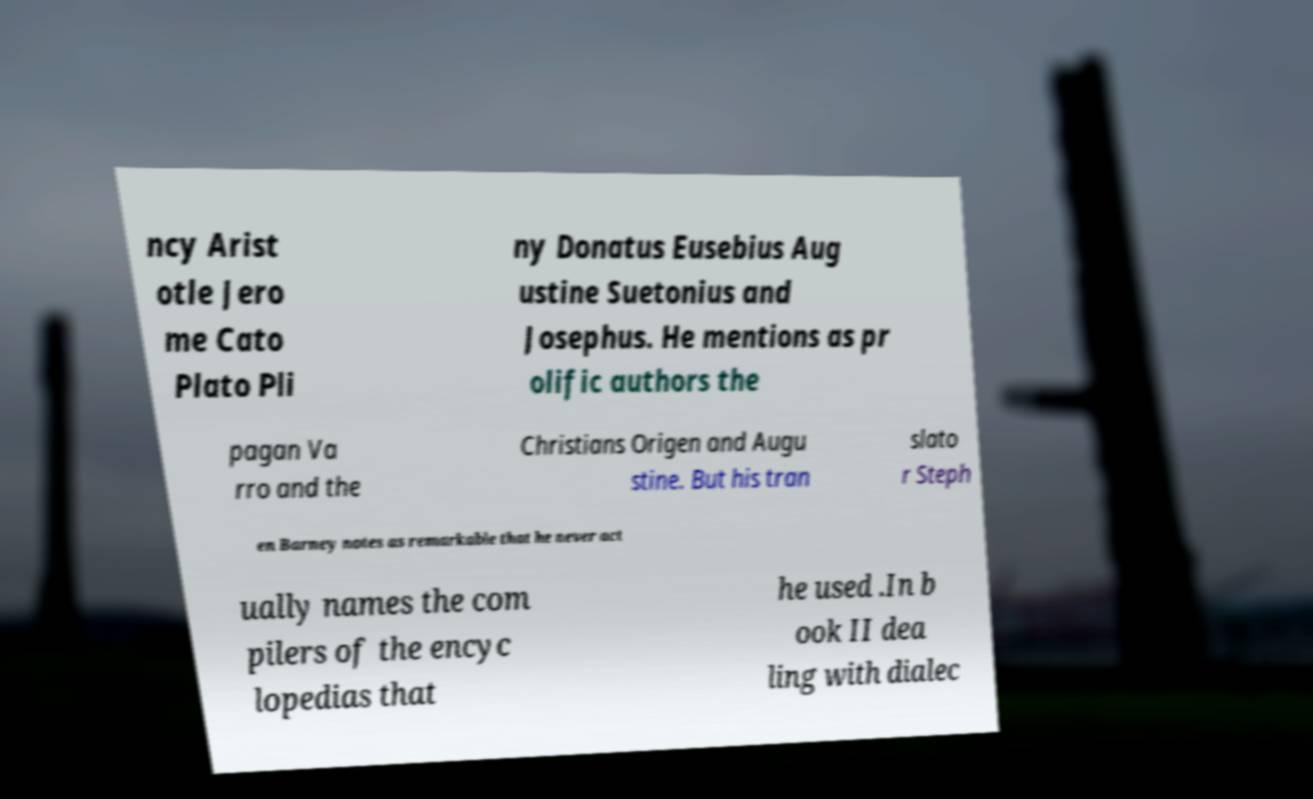Can you accurately transcribe the text from the provided image for me? ncy Arist otle Jero me Cato Plato Pli ny Donatus Eusebius Aug ustine Suetonius and Josephus. He mentions as pr olific authors the pagan Va rro and the Christians Origen and Augu stine. But his tran slato r Steph en Barney notes as remarkable that he never act ually names the com pilers of the encyc lopedias that he used .In b ook II dea ling with dialec 